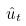<formula> <loc_0><loc_0><loc_500><loc_500>\hat { u } _ { t }</formula> 